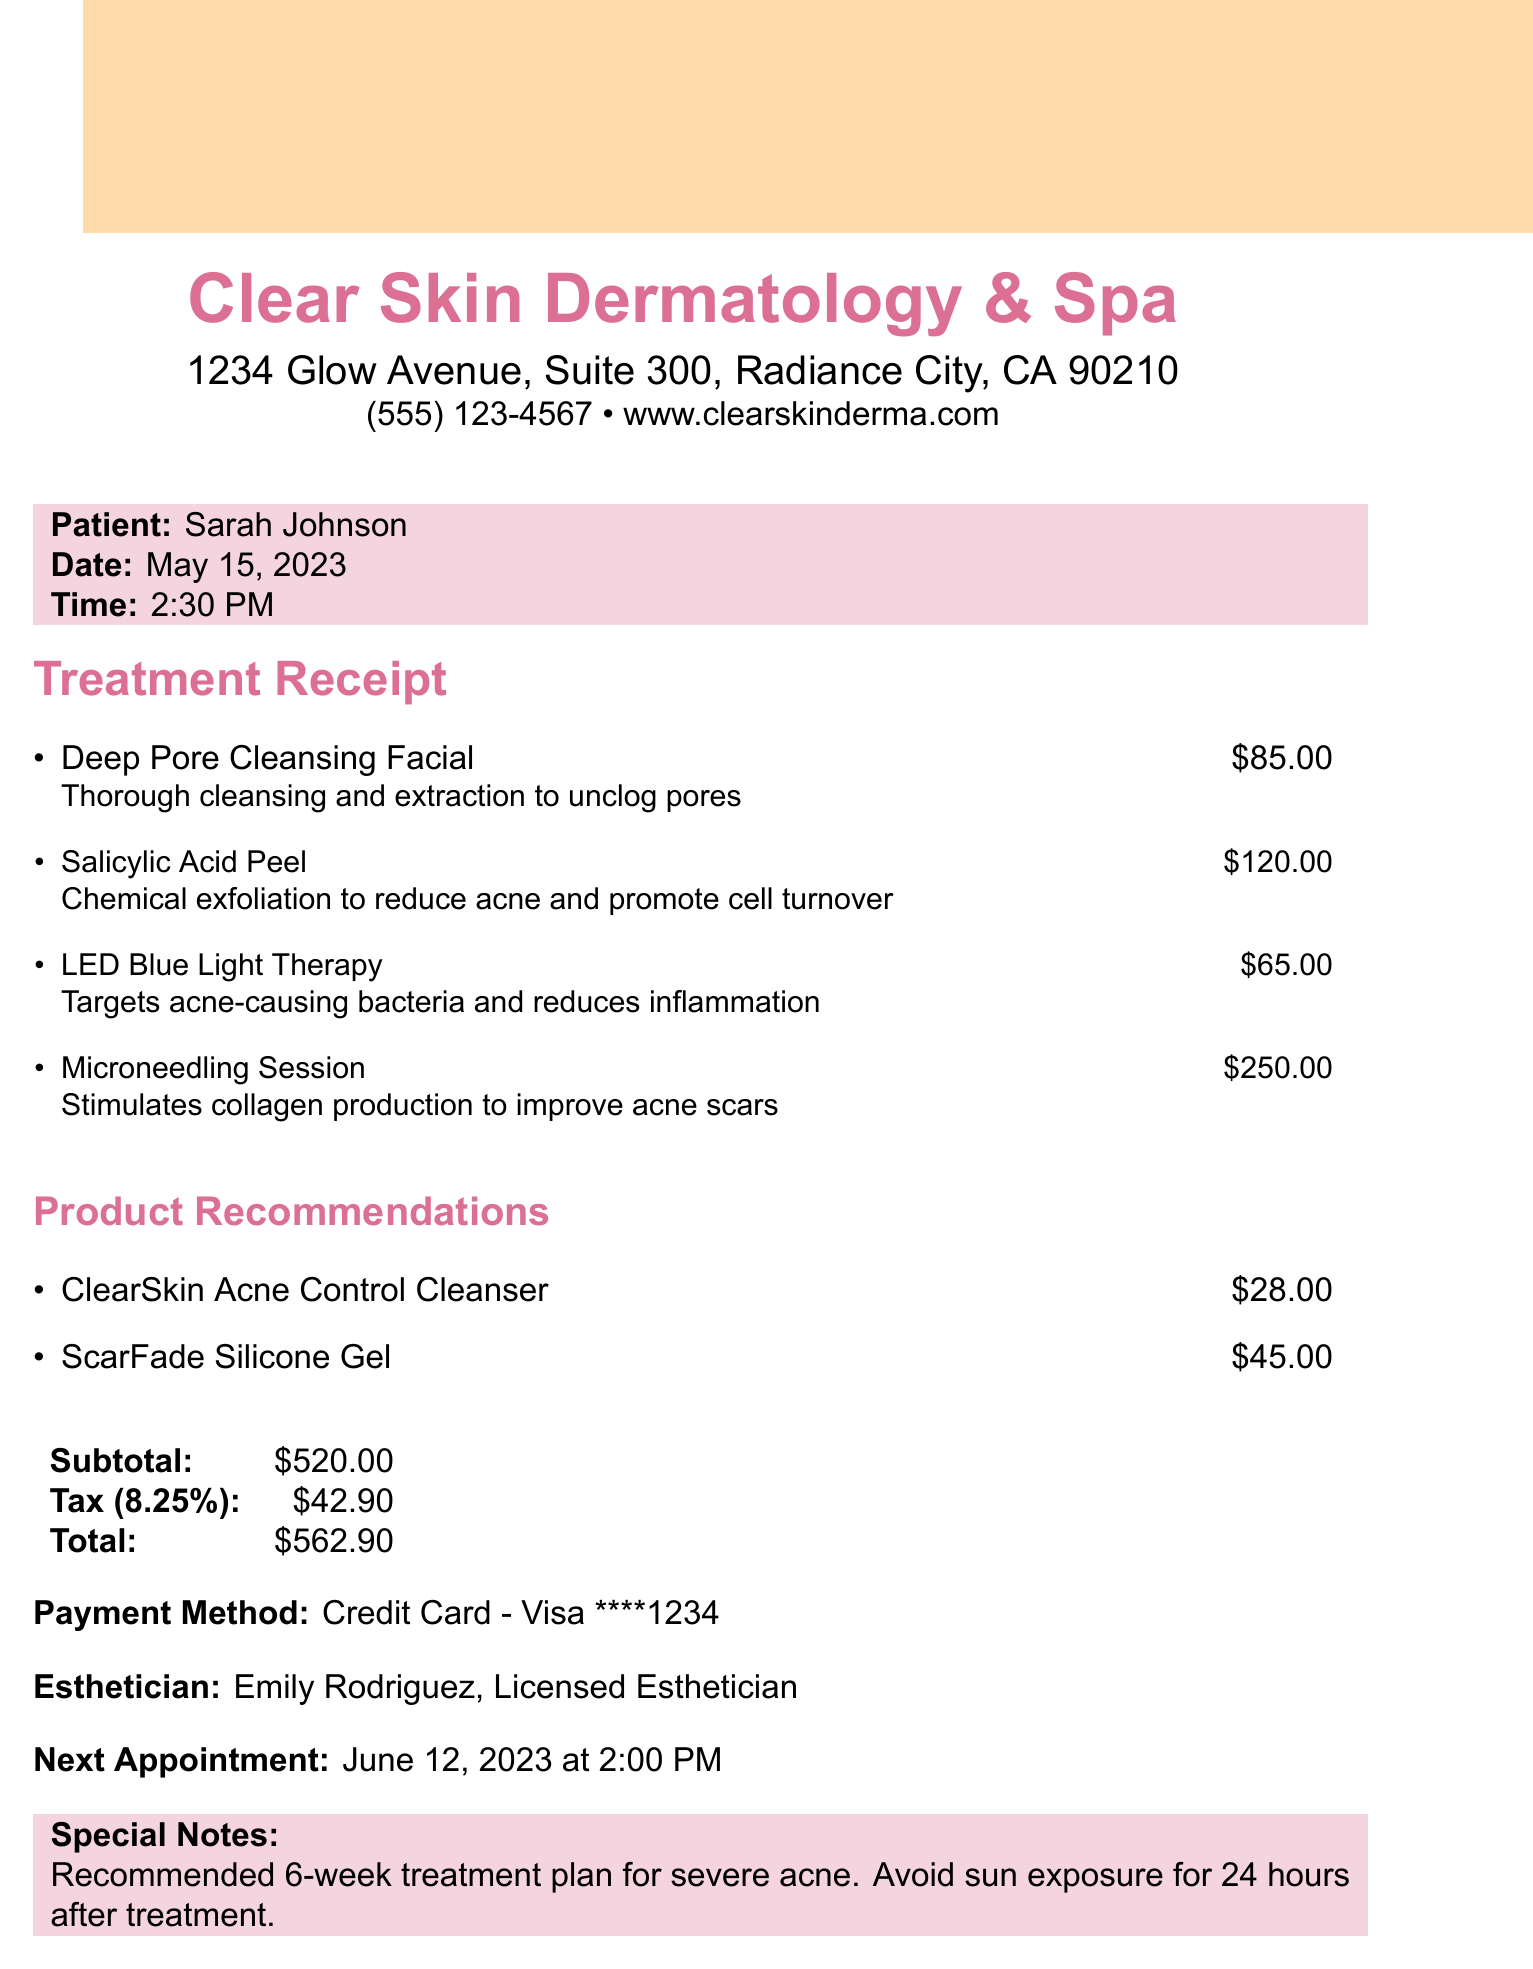What is the name of the business? The business name is clearly stated at the top of the document.
Answer: Clear Skin Dermatology & Spa What is the total amount billed? The total amount is calculated and displayed at the end of the receipt.
Answer: $562.90 Who was the esthetician for the treatment? The esthetician's name is mentioned in the body of the document.
Answer: Emily Rodriguez When is the next appointment scheduled? The next appointment date and time are provided in the document.
Answer: June 12, 2023 at 2:00 PM What type of facial treatment was administered? The first treatment item listed provides the name of the facial treatment.
Answer: Deep Pore Cleansing Facial What is the price of the Salicylic Acid Peel? Each treatment item's price is listed next to its name.
Answer: $120.00 What special note is included regarding sun exposure? The special note section includes important instructions after treatment.
Answer: Avoid sun exposure for 24 hours after treatment How much is the tax amount? The tax amount is calculated and shown in the totals section.
Answer: $42.90 